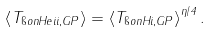Convert formula to latex. <formula><loc_0><loc_0><loc_500><loc_500>\left < T _ { \i o n { H e } { i i } , G P } \right > = \left < T _ { \i o n { H } { i } , G P } \right > ^ { \eta / 4 } .</formula> 